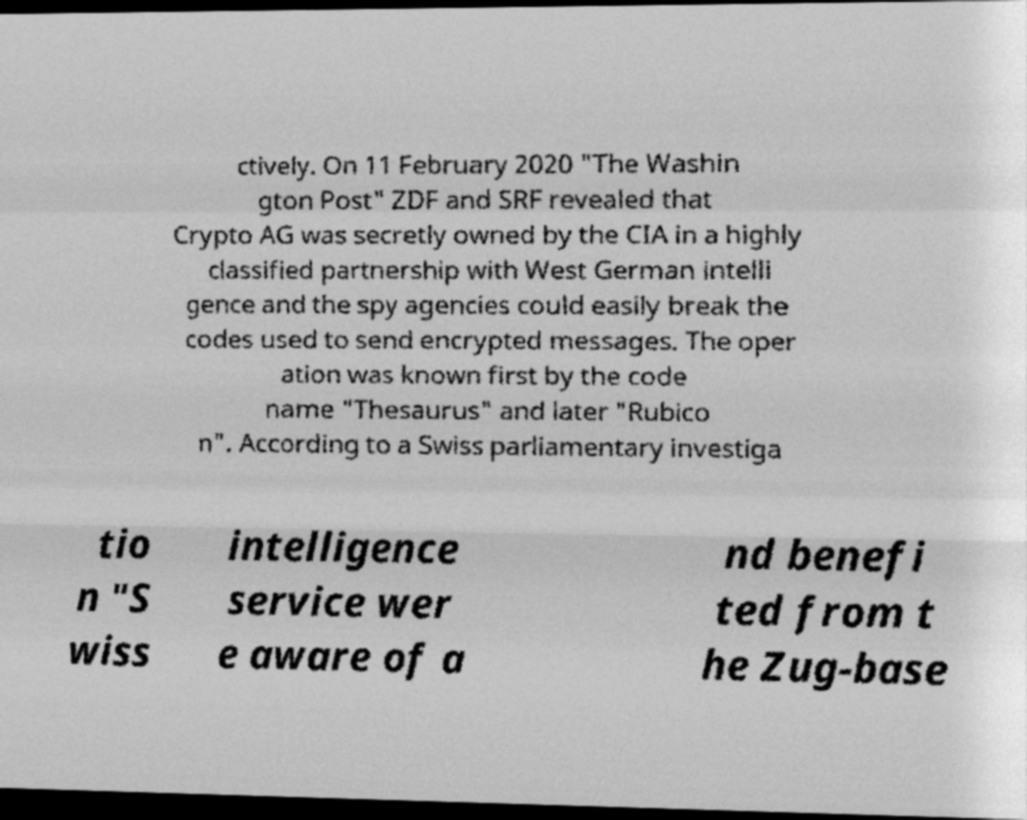Please read and relay the text visible in this image. What does it say? ctively. On 11 February 2020 "The Washin gton Post" ZDF and SRF revealed that Crypto AG was secretly owned by the CIA in a highly classified partnership with West German intelli gence and the spy agencies could easily break the codes used to send encrypted messages. The oper ation was known first by the code name "Thesaurus" and later "Rubico n". According to a Swiss parliamentary investiga tio n "S wiss intelligence service wer e aware of a nd benefi ted from t he Zug-base 